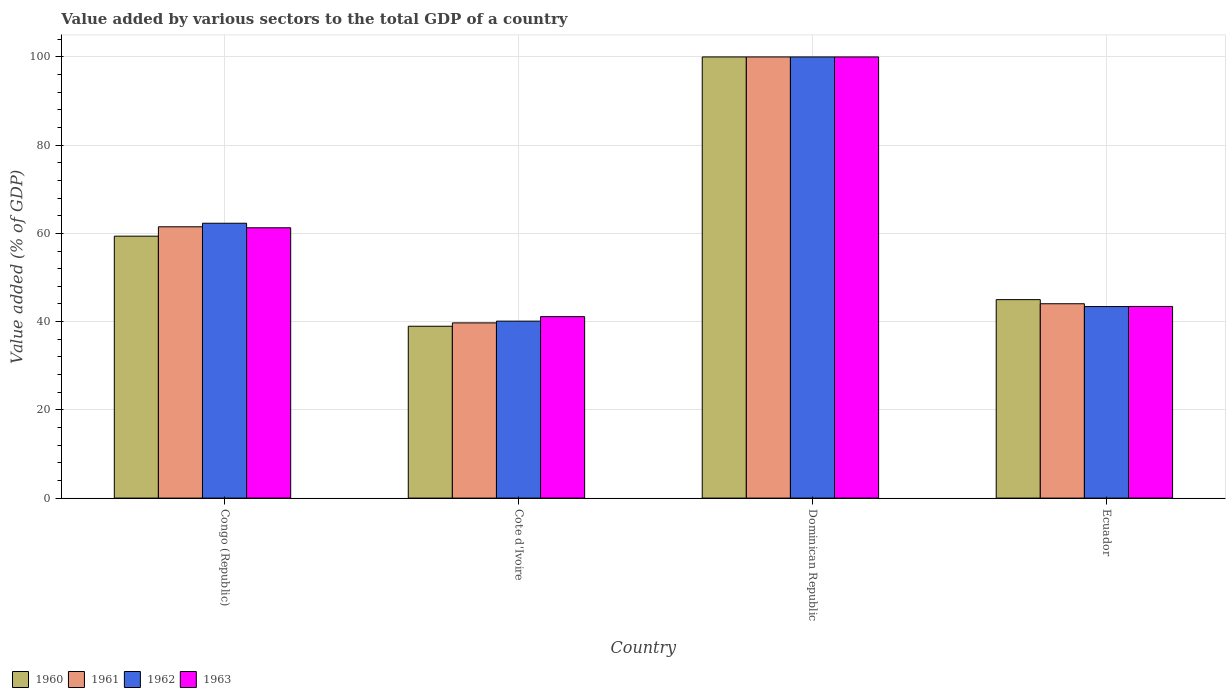Are the number of bars on each tick of the X-axis equal?
Make the answer very short. Yes. How many bars are there on the 4th tick from the right?
Offer a terse response. 4. What is the label of the 1st group of bars from the left?
Give a very brief answer. Congo (Republic). What is the value added by various sectors to the total GDP in 1963 in Cote d'Ivoire?
Keep it short and to the point. 41.13. Across all countries, what is the maximum value added by various sectors to the total GDP in 1961?
Offer a very short reply. 100. Across all countries, what is the minimum value added by various sectors to the total GDP in 1961?
Offer a very short reply. 39.71. In which country was the value added by various sectors to the total GDP in 1961 maximum?
Ensure brevity in your answer.  Dominican Republic. In which country was the value added by various sectors to the total GDP in 1962 minimum?
Your answer should be very brief. Cote d'Ivoire. What is the total value added by various sectors to the total GDP in 1962 in the graph?
Provide a succinct answer. 245.83. What is the difference between the value added by various sectors to the total GDP in 1961 in Cote d'Ivoire and that in Dominican Republic?
Ensure brevity in your answer.  -60.29. What is the difference between the value added by various sectors to the total GDP in 1962 in Dominican Republic and the value added by various sectors to the total GDP in 1961 in Ecuador?
Make the answer very short. 55.95. What is the average value added by various sectors to the total GDP in 1960 per country?
Your response must be concise. 60.83. What is the difference between the value added by various sectors to the total GDP of/in 1961 and value added by various sectors to the total GDP of/in 1963 in Ecuador?
Give a very brief answer. 0.61. What is the ratio of the value added by various sectors to the total GDP in 1961 in Congo (Republic) to that in Dominican Republic?
Give a very brief answer. 0.61. Is the value added by various sectors to the total GDP in 1961 in Congo (Republic) less than that in Ecuador?
Provide a succinct answer. No. Is the difference between the value added by various sectors to the total GDP in 1961 in Cote d'Ivoire and Ecuador greater than the difference between the value added by various sectors to the total GDP in 1963 in Cote d'Ivoire and Ecuador?
Offer a terse response. No. What is the difference between the highest and the second highest value added by various sectors to the total GDP in 1962?
Your answer should be very brief. -56.59. What is the difference between the highest and the lowest value added by various sectors to the total GDP in 1961?
Provide a short and direct response. 60.29. Is the sum of the value added by various sectors to the total GDP in 1961 in Cote d'Ivoire and Dominican Republic greater than the maximum value added by various sectors to the total GDP in 1962 across all countries?
Offer a very short reply. Yes. Is it the case that in every country, the sum of the value added by various sectors to the total GDP in 1960 and value added by various sectors to the total GDP in 1961 is greater than the value added by various sectors to the total GDP in 1963?
Keep it short and to the point. Yes. How many bars are there?
Offer a very short reply. 16. Are all the bars in the graph horizontal?
Keep it short and to the point. No. What is the difference between two consecutive major ticks on the Y-axis?
Offer a very short reply. 20. Does the graph contain any zero values?
Your answer should be compact. No. Does the graph contain grids?
Your answer should be compact. Yes. How many legend labels are there?
Provide a succinct answer. 4. How are the legend labels stacked?
Ensure brevity in your answer.  Horizontal. What is the title of the graph?
Make the answer very short. Value added by various sectors to the total GDP of a country. Does "1978" appear as one of the legend labels in the graph?
Provide a short and direct response. No. What is the label or title of the X-axis?
Your answer should be compact. Country. What is the label or title of the Y-axis?
Your answer should be very brief. Value added (% of GDP). What is the Value added (% of GDP) in 1960 in Congo (Republic)?
Your answer should be very brief. 59.37. What is the Value added (% of GDP) of 1961 in Congo (Republic)?
Provide a short and direct response. 61.5. What is the Value added (% of GDP) in 1962 in Congo (Republic)?
Ensure brevity in your answer.  62.3. What is the Value added (% of GDP) in 1963 in Congo (Republic)?
Your answer should be very brief. 61.27. What is the Value added (% of GDP) of 1960 in Cote d'Ivoire?
Offer a very short reply. 38.95. What is the Value added (% of GDP) in 1961 in Cote d'Ivoire?
Your answer should be very brief. 39.71. What is the Value added (% of GDP) of 1962 in Cote d'Ivoire?
Provide a succinct answer. 40.11. What is the Value added (% of GDP) in 1963 in Cote d'Ivoire?
Ensure brevity in your answer.  41.13. What is the Value added (% of GDP) in 1960 in Dominican Republic?
Your response must be concise. 100. What is the Value added (% of GDP) in 1961 in Dominican Republic?
Make the answer very short. 100. What is the Value added (% of GDP) in 1962 in Dominican Republic?
Offer a terse response. 100. What is the Value added (% of GDP) in 1963 in Dominican Republic?
Your answer should be very brief. 100. What is the Value added (% of GDP) in 1960 in Ecuador?
Make the answer very short. 44.99. What is the Value added (% of GDP) of 1961 in Ecuador?
Ensure brevity in your answer.  44.05. What is the Value added (% of GDP) of 1962 in Ecuador?
Provide a succinct answer. 43.41. What is the Value added (% of GDP) of 1963 in Ecuador?
Give a very brief answer. 43.44. Across all countries, what is the maximum Value added (% of GDP) in 1963?
Ensure brevity in your answer.  100. Across all countries, what is the minimum Value added (% of GDP) in 1960?
Give a very brief answer. 38.95. Across all countries, what is the minimum Value added (% of GDP) in 1961?
Your answer should be very brief. 39.71. Across all countries, what is the minimum Value added (% of GDP) of 1962?
Your response must be concise. 40.11. Across all countries, what is the minimum Value added (% of GDP) in 1963?
Your answer should be compact. 41.13. What is the total Value added (% of GDP) in 1960 in the graph?
Your answer should be compact. 243.31. What is the total Value added (% of GDP) in 1961 in the graph?
Provide a short and direct response. 245.27. What is the total Value added (% of GDP) in 1962 in the graph?
Make the answer very short. 245.83. What is the total Value added (% of GDP) of 1963 in the graph?
Your answer should be compact. 245.85. What is the difference between the Value added (% of GDP) in 1960 in Congo (Republic) and that in Cote d'Ivoire?
Your answer should be compact. 20.42. What is the difference between the Value added (% of GDP) in 1961 in Congo (Republic) and that in Cote d'Ivoire?
Your answer should be compact. 21.78. What is the difference between the Value added (% of GDP) of 1962 in Congo (Republic) and that in Cote d'Ivoire?
Your answer should be compact. 22.19. What is the difference between the Value added (% of GDP) of 1963 in Congo (Republic) and that in Cote d'Ivoire?
Provide a short and direct response. 20.14. What is the difference between the Value added (% of GDP) of 1960 in Congo (Republic) and that in Dominican Republic?
Keep it short and to the point. -40.63. What is the difference between the Value added (% of GDP) in 1961 in Congo (Republic) and that in Dominican Republic?
Your response must be concise. -38.5. What is the difference between the Value added (% of GDP) of 1962 in Congo (Republic) and that in Dominican Republic?
Ensure brevity in your answer.  -37.7. What is the difference between the Value added (% of GDP) in 1963 in Congo (Republic) and that in Dominican Republic?
Provide a short and direct response. -38.73. What is the difference between the Value added (% of GDP) in 1960 in Congo (Republic) and that in Ecuador?
Ensure brevity in your answer.  14.39. What is the difference between the Value added (% of GDP) in 1961 in Congo (Republic) and that in Ecuador?
Your answer should be compact. 17.44. What is the difference between the Value added (% of GDP) in 1962 in Congo (Republic) and that in Ecuador?
Ensure brevity in your answer.  18.89. What is the difference between the Value added (% of GDP) in 1963 in Congo (Republic) and that in Ecuador?
Your response must be concise. 17.83. What is the difference between the Value added (% of GDP) of 1960 in Cote d'Ivoire and that in Dominican Republic?
Keep it short and to the point. -61.05. What is the difference between the Value added (% of GDP) of 1961 in Cote d'Ivoire and that in Dominican Republic?
Ensure brevity in your answer.  -60.29. What is the difference between the Value added (% of GDP) in 1962 in Cote d'Ivoire and that in Dominican Republic?
Your response must be concise. -59.89. What is the difference between the Value added (% of GDP) of 1963 in Cote d'Ivoire and that in Dominican Republic?
Offer a very short reply. -58.87. What is the difference between the Value added (% of GDP) of 1960 in Cote d'Ivoire and that in Ecuador?
Your response must be concise. -6.03. What is the difference between the Value added (% of GDP) of 1961 in Cote d'Ivoire and that in Ecuador?
Ensure brevity in your answer.  -4.34. What is the difference between the Value added (% of GDP) of 1962 in Cote d'Ivoire and that in Ecuador?
Your response must be concise. -3.3. What is the difference between the Value added (% of GDP) in 1963 in Cote d'Ivoire and that in Ecuador?
Your answer should be very brief. -2.31. What is the difference between the Value added (% of GDP) in 1960 in Dominican Republic and that in Ecuador?
Your answer should be very brief. 55.02. What is the difference between the Value added (% of GDP) in 1961 in Dominican Republic and that in Ecuador?
Offer a very short reply. 55.95. What is the difference between the Value added (% of GDP) in 1962 in Dominican Republic and that in Ecuador?
Make the answer very short. 56.59. What is the difference between the Value added (% of GDP) in 1963 in Dominican Republic and that in Ecuador?
Your answer should be compact. 56.56. What is the difference between the Value added (% of GDP) in 1960 in Congo (Republic) and the Value added (% of GDP) in 1961 in Cote d'Ivoire?
Give a very brief answer. 19.66. What is the difference between the Value added (% of GDP) of 1960 in Congo (Republic) and the Value added (% of GDP) of 1962 in Cote d'Ivoire?
Make the answer very short. 19.26. What is the difference between the Value added (% of GDP) of 1960 in Congo (Republic) and the Value added (% of GDP) of 1963 in Cote d'Ivoire?
Your answer should be compact. 18.24. What is the difference between the Value added (% of GDP) of 1961 in Congo (Republic) and the Value added (% of GDP) of 1962 in Cote d'Ivoire?
Provide a short and direct response. 21.38. What is the difference between the Value added (% of GDP) in 1961 in Congo (Republic) and the Value added (% of GDP) in 1963 in Cote d'Ivoire?
Keep it short and to the point. 20.36. What is the difference between the Value added (% of GDP) of 1962 in Congo (Republic) and the Value added (% of GDP) of 1963 in Cote d'Ivoire?
Your answer should be compact. 21.17. What is the difference between the Value added (% of GDP) in 1960 in Congo (Republic) and the Value added (% of GDP) in 1961 in Dominican Republic?
Your response must be concise. -40.63. What is the difference between the Value added (% of GDP) in 1960 in Congo (Republic) and the Value added (% of GDP) in 1962 in Dominican Republic?
Provide a succinct answer. -40.63. What is the difference between the Value added (% of GDP) in 1960 in Congo (Republic) and the Value added (% of GDP) in 1963 in Dominican Republic?
Provide a short and direct response. -40.63. What is the difference between the Value added (% of GDP) in 1961 in Congo (Republic) and the Value added (% of GDP) in 1962 in Dominican Republic?
Offer a very short reply. -38.5. What is the difference between the Value added (% of GDP) in 1961 in Congo (Republic) and the Value added (% of GDP) in 1963 in Dominican Republic?
Provide a short and direct response. -38.5. What is the difference between the Value added (% of GDP) in 1962 in Congo (Republic) and the Value added (% of GDP) in 1963 in Dominican Republic?
Your answer should be compact. -37.7. What is the difference between the Value added (% of GDP) in 1960 in Congo (Republic) and the Value added (% of GDP) in 1961 in Ecuador?
Keep it short and to the point. 15.32. What is the difference between the Value added (% of GDP) of 1960 in Congo (Republic) and the Value added (% of GDP) of 1962 in Ecuador?
Your answer should be very brief. 15.96. What is the difference between the Value added (% of GDP) in 1960 in Congo (Republic) and the Value added (% of GDP) in 1963 in Ecuador?
Your answer should be very brief. 15.93. What is the difference between the Value added (% of GDP) of 1961 in Congo (Republic) and the Value added (% of GDP) of 1962 in Ecuador?
Your answer should be compact. 18.08. What is the difference between the Value added (% of GDP) of 1961 in Congo (Republic) and the Value added (% of GDP) of 1963 in Ecuador?
Ensure brevity in your answer.  18.06. What is the difference between the Value added (% of GDP) of 1962 in Congo (Republic) and the Value added (% of GDP) of 1963 in Ecuador?
Your answer should be very brief. 18.86. What is the difference between the Value added (% of GDP) of 1960 in Cote d'Ivoire and the Value added (% of GDP) of 1961 in Dominican Republic?
Make the answer very short. -61.05. What is the difference between the Value added (% of GDP) of 1960 in Cote d'Ivoire and the Value added (% of GDP) of 1962 in Dominican Republic?
Your answer should be very brief. -61.05. What is the difference between the Value added (% of GDP) in 1960 in Cote d'Ivoire and the Value added (% of GDP) in 1963 in Dominican Republic?
Provide a short and direct response. -61.05. What is the difference between the Value added (% of GDP) of 1961 in Cote d'Ivoire and the Value added (% of GDP) of 1962 in Dominican Republic?
Your answer should be compact. -60.29. What is the difference between the Value added (% of GDP) of 1961 in Cote d'Ivoire and the Value added (% of GDP) of 1963 in Dominican Republic?
Your answer should be compact. -60.29. What is the difference between the Value added (% of GDP) in 1962 in Cote d'Ivoire and the Value added (% of GDP) in 1963 in Dominican Republic?
Offer a terse response. -59.89. What is the difference between the Value added (% of GDP) of 1960 in Cote d'Ivoire and the Value added (% of GDP) of 1961 in Ecuador?
Give a very brief answer. -5.1. What is the difference between the Value added (% of GDP) in 1960 in Cote d'Ivoire and the Value added (% of GDP) in 1962 in Ecuador?
Keep it short and to the point. -4.46. What is the difference between the Value added (% of GDP) of 1960 in Cote d'Ivoire and the Value added (% of GDP) of 1963 in Ecuador?
Offer a very short reply. -4.49. What is the difference between the Value added (% of GDP) in 1961 in Cote d'Ivoire and the Value added (% of GDP) in 1962 in Ecuador?
Offer a terse response. -3.7. What is the difference between the Value added (% of GDP) in 1961 in Cote d'Ivoire and the Value added (% of GDP) in 1963 in Ecuador?
Ensure brevity in your answer.  -3.73. What is the difference between the Value added (% of GDP) of 1962 in Cote d'Ivoire and the Value added (% of GDP) of 1963 in Ecuador?
Your response must be concise. -3.33. What is the difference between the Value added (% of GDP) of 1960 in Dominican Republic and the Value added (% of GDP) of 1961 in Ecuador?
Give a very brief answer. 55.95. What is the difference between the Value added (% of GDP) in 1960 in Dominican Republic and the Value added (% of GDP) in 1962 in Ecuador?
Your answer should be very brief. 56.59. What is the difference between the Value added (% of GDP) in 1960 in Dominican Republic and the Value added (% of GDP) in 1963 in Ecuador?
Make the answer very short. 56.56. What is the difference between the Value added (% of GDP) in 1961 in Dominican Republic and the Value added (% of GDP) in 1962 in Ecuador?
Provide a succinct answer. 56.59. What is the difference between the Value added (% of GDP) in 1961 in Dominican Republic and the Value added (% of GDP) in 1963 in Ecuador?
Keep it short and to the point. 56.56. What is the difference between the Value added (% of GDP) of 1962 in Dominican Republic and the Value added (% of GDP) of 1963 in Ecuador?
Your response must be concise. 56.56. What is the average Value added (% of GDP) of 1960 per country?
Provide a short and direct response. 60.83. What is the average Value added (% of GDP) of 1961 per country?
Ensure brevity in your answer.  61.32. What is the average Value added (% of GDP) in 1962 per country?
Your answer should be very brief. 61.46. What is the average Value added (% of GDP) of 1963 per country?
Provide a short and direct response. 61.46. What is the difference between the Value added (% of GDP) in 1960 and Value added (% of GDP) in 1961 in Congo (Republic)?
Offer a very short reply. -2.13. What is the difference between the Value added (% of GDP) in 1960 and Value added (% of GDP) in 1962 in Congo (Republic)?
Ensure brevity in your answer.  -2.93. What is the difference between the Value added (% of GDP) of 1960 and Value added (% of GDP) of 1963 in Congo (Republic)?
Your answer should be compact. -1.9. What is the difference between the Value added (% of GDP) of 1961 and Value added (% of GDP) of 1962 in Congo (Republic)?
Offer a terse response. -0.81. What is the difference between the Value added (% of GDP) in 1961 and Value added (% of GDP) in 1963 in Congo (Republic)?
Your answer should be compact. 0.22. What is the difference between the Value added (% of GDP) in 1962 and Value added (% of GDP) in 1963 in Congo (Republic)?
Your response must be concise. 1.03. What is the difference between the Value added (% of GDP) in 1960 and Value added (% of GDP) in 1961 in Cote d'Ivoire?
Make the answer very short. -0.76. What is the difference between the Value added (% of GDP) in 1960 and Value added (% of GDP) in 1962 in Cote d'Ivoire?
Keep it short and to the point. -1.16. What is the difference between the Value added (% of GDP) in 1960 and Value added (% of GDP) in 1963 in Cote d'Ivoire?
Your response must be concise. -2.18. What is the difference between the Value added (% of GDP) of 1961 and Value added (% of GDP) of 1962 in Cote d'Ivoire?
Provide a short and direct response. -0.4. What is the difference between the Value added (% of GDP) of 1961 and Value added (% of GDP) of 1963 in Cote d'Ivoire?
Offer a terse response. -1.42. What is the difference between the Value added (% of GDP) in 1962 and Value added (% of GDP) in 1963 in Cote d'Ivoire?
Your answer should be very brief. -1.02. What is the difference between the Value added (% of GDP) of 1960 and Value added (% of GDP) of 1961 in Dominican Republic?
Provide a short and direct response. 0. What is the difference between the Value added (% of GDP) of 1960 and Value added (% of GDP) of 1962 in Dominican Republic?
Your answer should be compact. 0. What is the difference between the Value added (% of GDP) of 1960 and Value added (% of GDP) of 1963 in Dominican Republic?
Offer a very short reply. 0. What is the difference between the Value added (% of GDP) in 1961 and Value added (% of GDP) in 1962 in Dominican Republic?
Your answer should be compact. 0. What is the difference between the Value added (% of GDP) in 1960 and Value added (% of GDP) in 1961 in Ecuador?
Offer a very short reply. 0.93. What is the difference between the Value added (% of GDP) in 1960 and Value added (% of GDP) in 1962 in Ecuador?
Offer a very short reply. 1.57. What is the difference between the Value added (% of GDP) of 1960 and Value added (% of GDP) of 1963 in Ecuador?
Your answer should be compact. 1.54. What is the difference between the Value added (% of GDP) in 1961 and Value added (% of GDP) in 1962 in Ecuador?
Offer a terse response. 0.64. What is the difference between the Value added (% of GDP) of 1961 and Value added (% of GDP) of 1963 in Ecuador?
Offer a very short reply. 0.61. What is the difference between the Value added (% of GDP) of 1962 and Value added (% of GDP) of 1963 in Ecuador?
Your answer should be very brief. -0.03. What is the ratio of the Value added (% of GDP) in 1960 in Congo (Republic) to that in Cote d'Ivoire?
Offer a terse response. 1.52. What is the ratio of the Value added (% of GDP) of 1961 in Congo (Republic) to that in Cote d'Ivoire?
Offer a very short reply. 1.55. What is the ratio of the Value added (% of GDP) of 1962 in Congo (Republic) to that in Cote d'Ivoire?
Your answer should be very brief. 1.55. What is the ratio of the Value added (% of GDP) in 1963 in Congo (Republic) to that in Cote d'Ivoire?
Ensure brevity in your answer.  1.49. What is the ratio of the Value added (% of GDP) in 1960 in Congo (Republic) to that in Dominican Republic?
Offer a terse response. 0.59. What is the ratio of the Value added (% of GDP) in 1961 in Congo (Republic) to that in Dominican Republic?
Offer a terse response. 0.61. What is the ratio of the Value added (% of GDP) in 1962 in Congo (Republic) to that in Dominican Republic?
Your answer should be compact. 0.62. What is the ratio of the Value added (% of GDP) in 1963 in Congo (Republic) to that in Dominican Republic?
Keep it short and to the point. 0.61. What is the ratio of the Value added (% of GDP) in 1960 in Congo (Republic) to that in Ecuador?
Give a very brief answer. 1.32. What is the ratio of the Value added (% of GDP) of 1961 in Congo (Republic) to that in Ecuador?
Keep it short and to the point. 1.4. What is the ratio of the Value added (% of GDP) of 1962 in Congo (Republic) to that in Ecuador?
Offer a very short reply. 1.44. What is the ratio of the Value added (% of GDP) in 1963 in Congo (Republic) to that in Ecuador?
Your answer should be compact. 1.41. What is the ratio of the Value added (% of GDP) of 1960 in Cote d'Ivoire to that in Dominican Republic?
Give a very brief answer. 0.39. What is the ratio of the Value added (% of GDP) of 1961 in Cote d'Ivoire to that in Dominican Republic?
Your answer should be compact. 0.4. What is the ratio of the Value added (% of GDP) of 1962 in Cote d'Ivoire to that in Dominican Republic?
Provide a short and direct response. 0.4. What is the ratio of the Value added (% of GDP) in 1963 in Cote d'Ivoire to that in Dominican Republic?
Give a very brief answer. 0.41. What is the ratio of the Value added (% of GDP) of 1960 in Cote d'Ivoire to that in Ecuador?
Give a very brief answer. 0.87. What is the ratio of the Value added (% of GDP) of 1961 in Cote d'Ivoire to that in Ecuador?
Give a very brief answer. 0.9. What is the ratio of the Value added (% of GDP) of 1962 in Cote d'Ivoire to that in Ecuador?
Make the answer very short. 0.92. What is the ratio of the Value added (% of GDP) in 1963 in Cote d'Ivoire to that in Ecuador?
Provide a succinct answer. 0.95. What is the ratio of the Value added (% of GDP) of 1960 in Dominican Republic to that in Ecuador?
Make the answer very short. 2.22. What is the ratio of the Value added (% of GDP) in 1961 in Dominican Republic to that in Ecuador?
Offer a very short reply. 2.27. What is the ratio of the Value added (% of GDP) in 1962 in Dominican Republic to that in Ecuador?
Your response must be concise. 2.3. What is the ratio of the Value added (% of GDP) in 1963 in Dominican Republic to that in Ecuador?
Your answer should be compact. 2.3. What is the difference between the highest and the second highest Value added (% of GDP) of 1960?
Keep it short and to the point. 40.63. What is the difference between the highest and the second highest Value added (% of GDP) of 1961?
Your response must be concise. 38.5. What is the difference between the highest and the second highest Value added (% of GDP) in 1962?
Give a very brief answer. 37.7. What is the difference between the highest and the second highest Value added (% of GDP) in 1963?
Your response must be concise. 38.73. What is the difference between the highest and the lowest Value added (% of GDP) in 1960?
Your response must be concise. 61.05. What is the difference between the highest and the lowest Value added (% of GDP) of 1961?
Provide a succinct answer. 60.29. What is the difference between the highest and the lowest Value added (% of GDP) in 1962?
Provide a succinct answer. 59.89. What is the difference between the highest and the lowest Value added (% of GDP) in 1963?
Give a very brief answer. 58.87. 